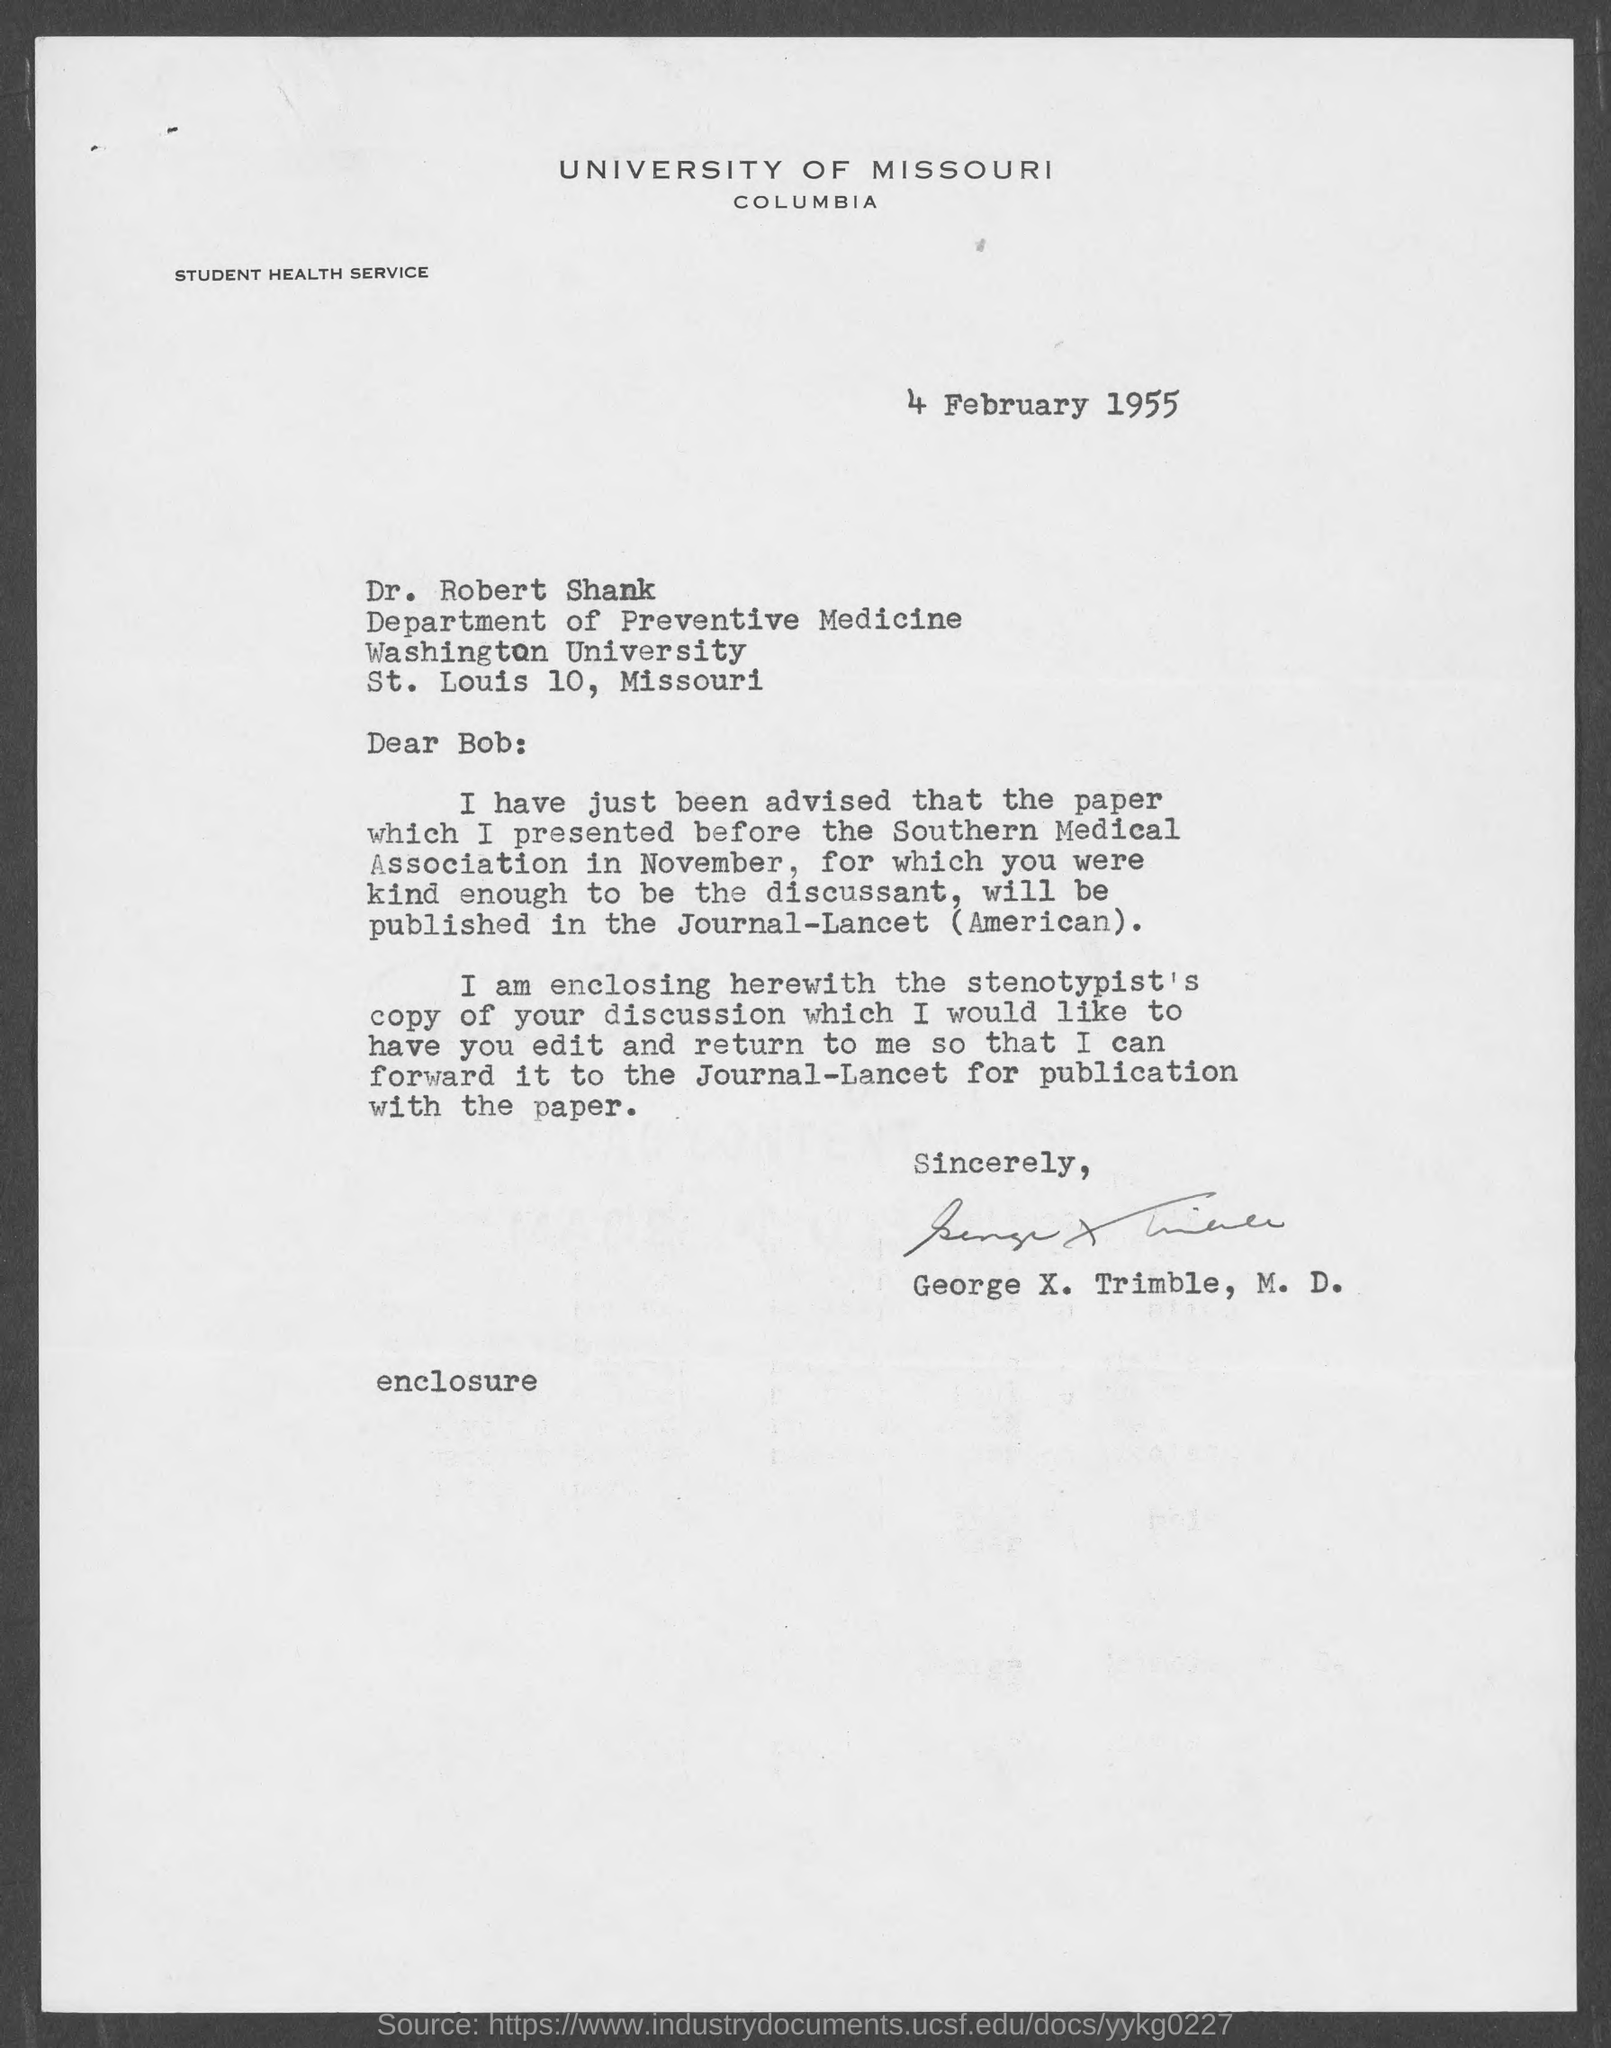Who wrote this letter?
Your answer should be compact. George X. Trimble, M.D. The letter is dated on?
Offer a terse response. 4 February 1955. To whom is this letter written to?
Provide a succinct answer. Dr. Robert Shank. To which department does Dr.Robert Shank belong to?
Your answer should be compact. Department of Preventive Medicine. What is the address of washington university?
Your answer should be very brief. St. Louis 10, Missouri. 